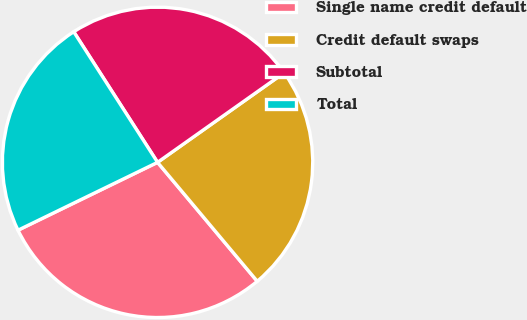<chart> <loc_0><loc_0><loc_500><loc_500><pie_chart><fcel>Single name credit default<fcel>Credit default swaps<fcel>Subtotal<fcel>Total<nl><fcel>28.9%<fcel>23.7%<fcel>24.28%<fcel>23.12%<nl></chart> 